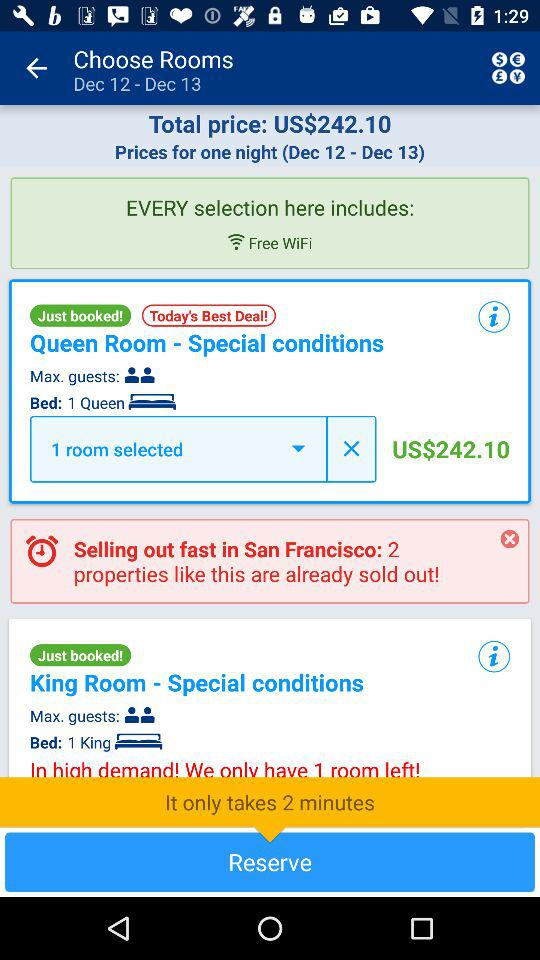What date range is given? The given date range is December 12 to December 13. 